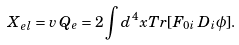<formula> <loc_0><loc_0><loc_500><loc_500>X _ { e l } = v \, Q _ { e } = 2 \int d ^ { 4 } x T r [ F _ { 0 i } \, D _ { i } \phi ] .</formula> 